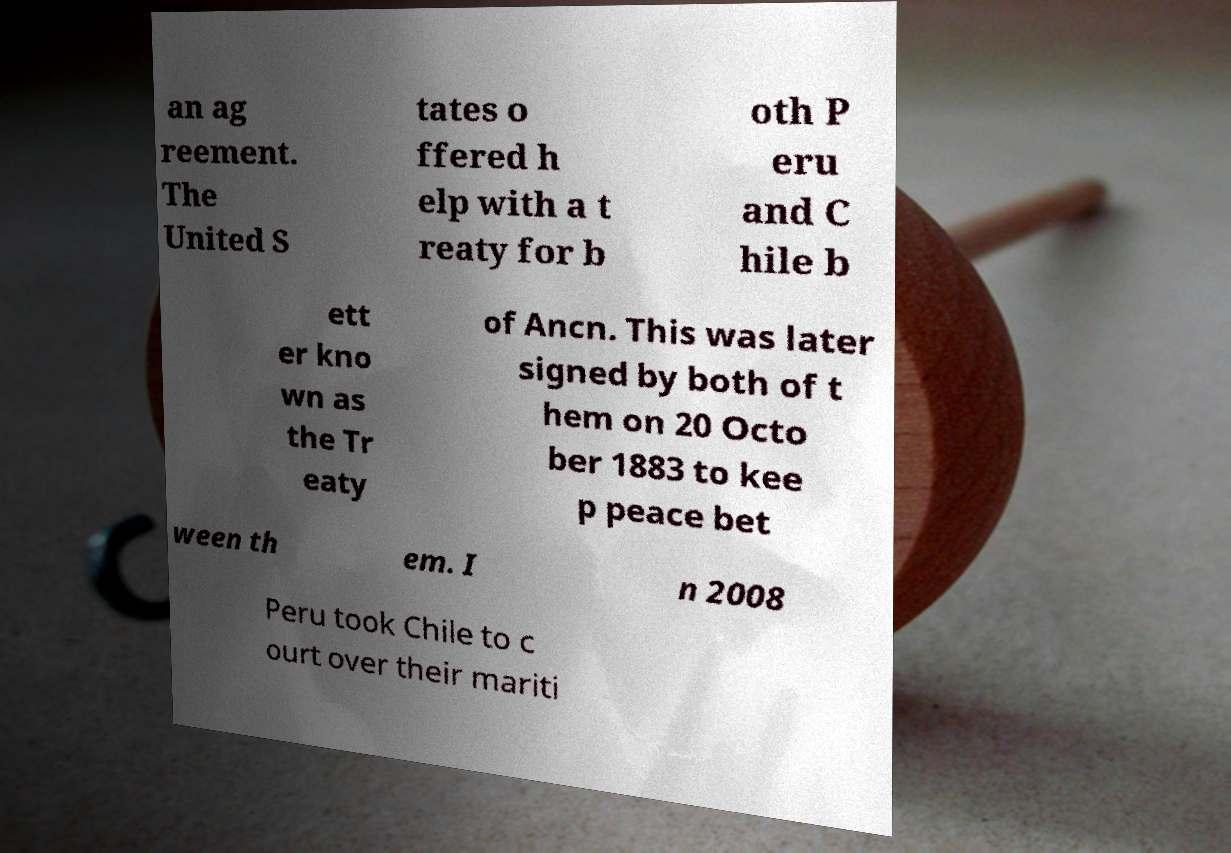Can you read and provide the text displayed in the image?This photo seems to have some interesting text. Can you extract and type it out for me? an ag reement. The United S tates o ffered h elp with a t reaty for b oth P eru and C hile b ett er kno wn as the Tr eaty of Ancn. This was later signed by both of t hem on 20 Octo ber 1883 to kee p peace bet ween th em. I n 2008 Peru took Chile to c ourt over their mariti 